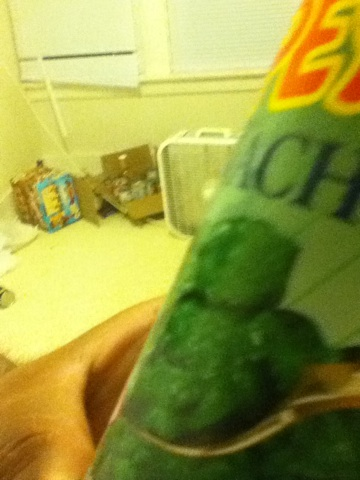Could you use this can of spinach in a recipe? Certainly! Canned spinach is great for recipes like spinach dip, quiche, pasta dishes, or even a simple spinach side dish seasoned with garlic. 